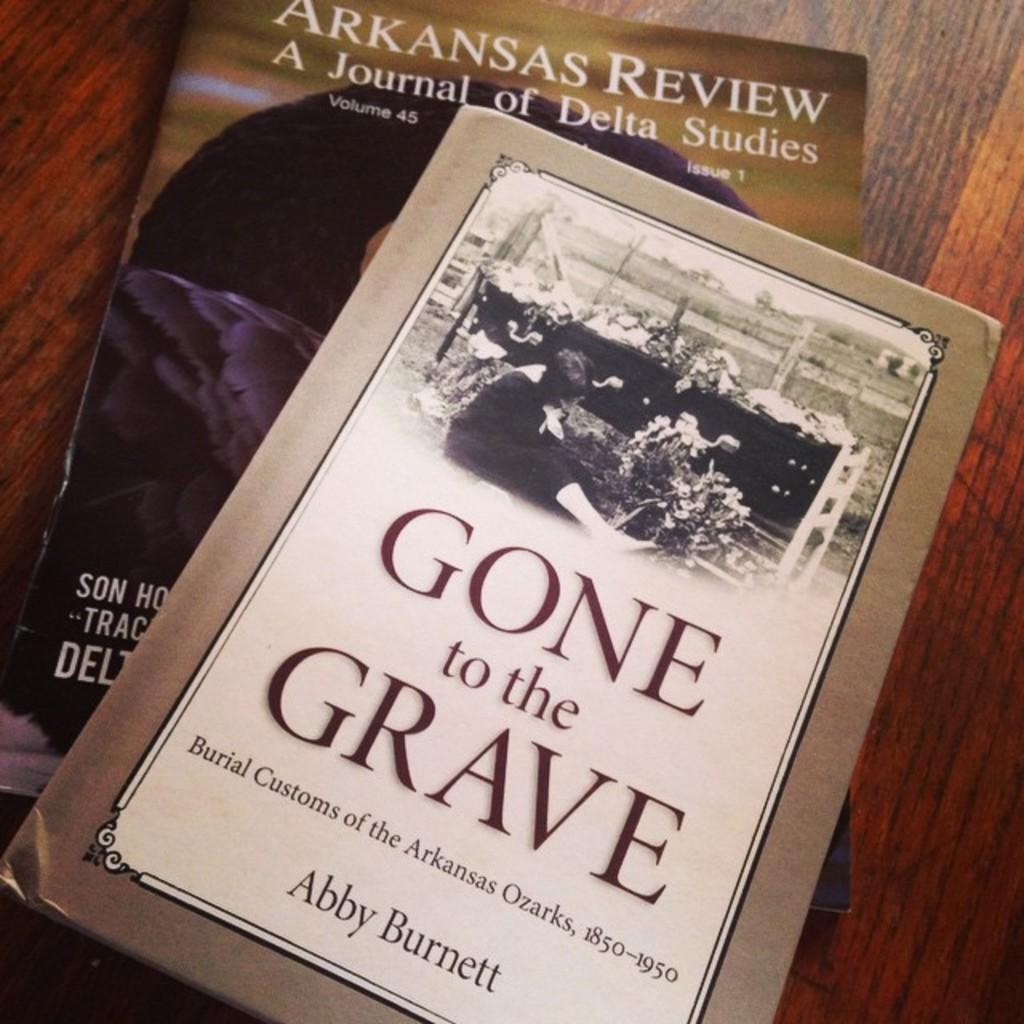<image>
Render a clear and concise summary of the photo. A book written by Abby Burnett is laying on a table top. 